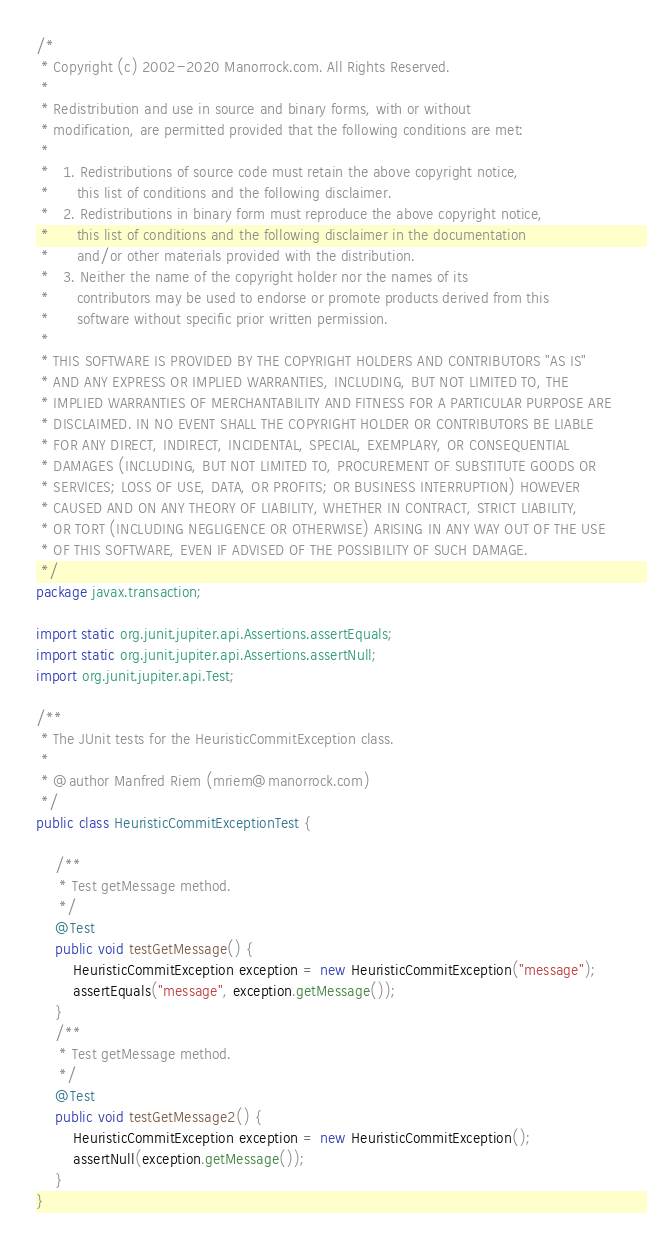<code> <loc_0><loc_0><loc_500><loc_500><_Java_>/*
 * Copyright (c) 2002-2020 Manorrock.com. All Rights Reserved.
 *
 * Redistribution and use in source and binary forms, with or without 
 * modification, are permitted provided that the following conditions are met:
 *
 *   1. Redistributions of source code must retain the above copyright notice, 
 *      this list of conditions and the following disclaimer.
 *   2. Redistributions in binary form must reproduce the above copyright notice,
 *      this list of conditions and the following disclaimer in the documentation
 *      and/or other materials provided with the distribution.
 *   3. Neither the name of the copyright holder nor the names of its 
 *      contributors may be used to endorse or promote products derived from this
 *      software without specific prior written permission.
 *
 * THIS SOFTWARE IS PROVIDED BY THE COPYRIGHT HOLDERS AND CONTRIBUTORS "AS IS" 
 * AND ANY EXPRESS OR IMPLIED WARRANTIES, INCLUDING, BUT NOT LIMITED TO, THE 
 * IMPLIED WARRANTIES OF MERCHANTABILITY AND FITNESS FOR A PARTICULAR PURPOSE ARE
 * DISCLAIMED. IN NO EVENT SHALL THE COPYRIGHT HOLDER OR CONTRIBUTORS BE LIABLE
 * FOR ANY DIRECT, INDIRECT, INCIDENTAL, SPECIAL, EXEMPLARY, OR CONSEQUENTIAL
 * DAMAGES (INCLUDING, BUT NOT LIMITED TO, PROCUREMENT OF SUBSTITUTE GOODS OR
 * SERVICES; LOSS OF USE, DATA, OR PROFITS; OR BUSINESS INTERRUPTION) HOWEVER
 * CAUSED AND ON ANY THEORY OF LIABILITY, WHETHER IN CONTRACT, STRICT LIABILITY,
 * OR TORT (INCLUDING NEGLIGENCE OR OTHERWISE) ARISING IN ANY WAY OUT OF THE USE
 * OF THIS SOFTWARE, EVEN IF ADVISED OF THE POSSIBILITY OF SUCH DAMAGE.
 */
package javax.transaction;

import static org.junit.jupiter.api.Assertions.assertEquals;
import static org.junit.jupiter.api.Assertions.assertNull;
import org.junit.jupiter.api.Test;

/**
 * The JUnit tests for the HeuristicCommitException class.
 * 
 * @author Manfred Riem (mriem@manorrock.com)
 */
public class HeuristicCommitExceptionTest {
    
    /**
     * Test getMessage method.
     */
    @Test
    public void testGetMessage() {
        HeuristicCommitException exception = new HeuristicCommitException("message");
        assertEquals("message", exception.getMessage());
    }    
    /**
     * Test getMessage method.
     */
    @Test
    public void testGetMessage2() {
        HeuristicCommitException exception = new HeuristicCommitException();
        assertNull(exception.getMessage());
    }
}
</code> 